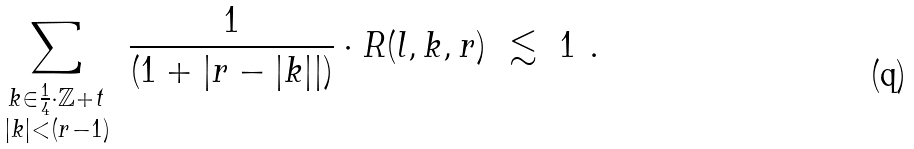Convert formula to latex. <formula><loc_0><loc_0><loc_500><loc_500>\sum _ { \substack { k \in \frac { 1 } { 4 } \cdot \mathbb { Z } + t \\ | k | < ( r - 1 ) } } \ \frac { 1 } { ( 1 + \left | r - | k | \right | ) } \cdot R ( l , k , r ) \ \lesssim \ 1 \ .</formula> 